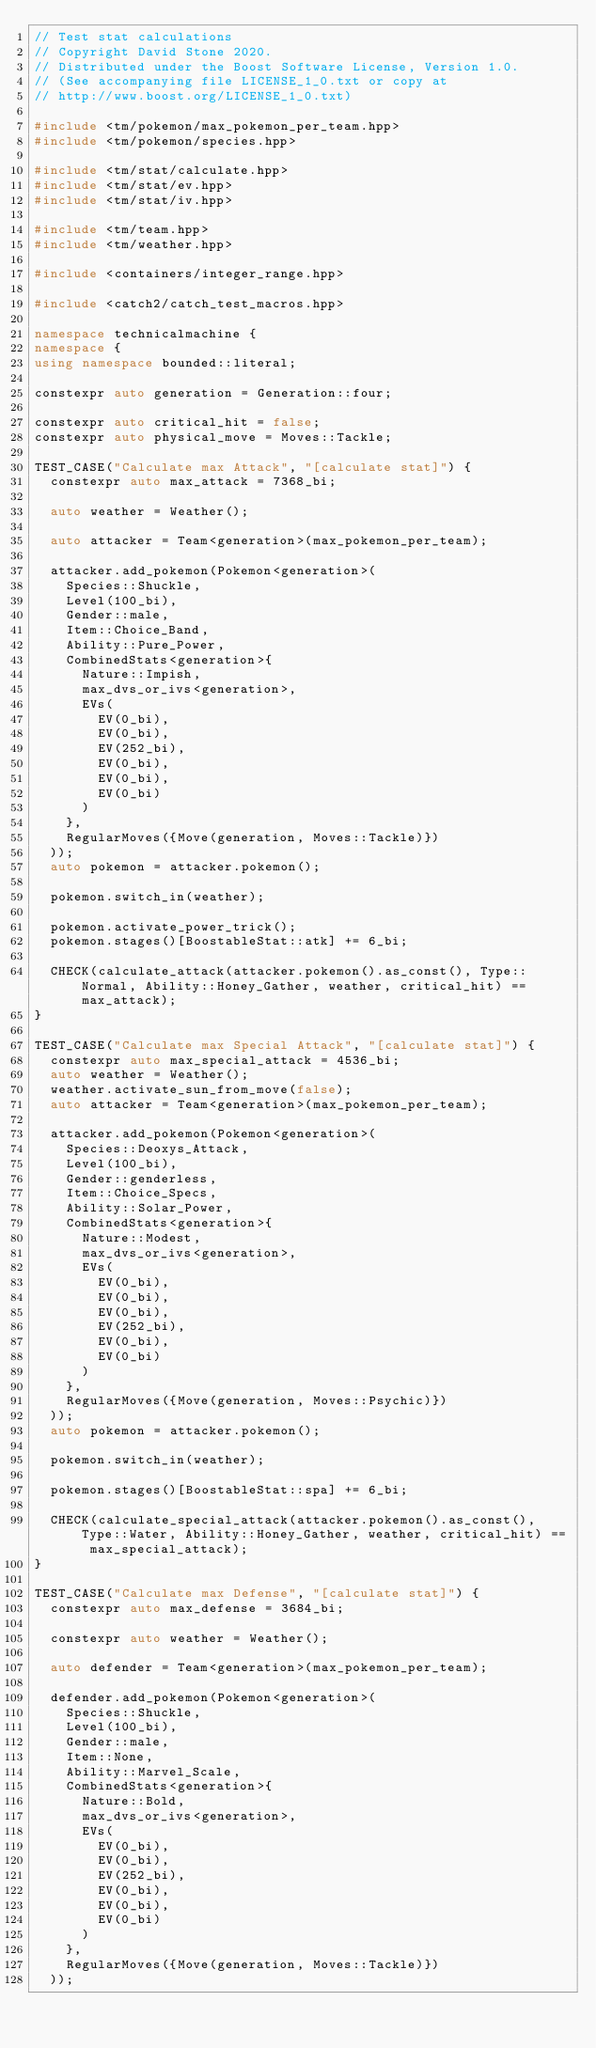<code> <loc_0><loc_0><loc_500><loc_500><_C++_>// Test stat calculations
// Copyright David Stone 2020.
// Distributed under the Boost Software License, Version 1.0.
// (See accompanying file LICENSE_1_0.txt or copy at
// http://www.boost.org/LICENSE_1_0.txt)

#include <tm/pokemon/max_pokemon_per_team.hpp>
#include <tm/pokemon/species.hpp>

#include <tm/stat/calculate.hpp>
#include <tm/stat/ev.hpp>
#include <tm/stat/iv.hpp>

#include <tm/team.hpp>
#include <tm/weather.hpp>

#include <containers/integer_range.hpp>

#include <catch2/catch_test_macros.hpp>

namespace technicalmachine {
namespace {
using namespace bounded::literal;

constexpr auto generation = Generation::four;

constexpr auto critical_hit = false;
constexpr auto physical_move = Moves::Tackle;

TEST_CASE("Calculate max Attack", "[calculate stat]") {
	constexpr auto max_attack = 7368_bi;

	auto weather = Weather();

	auto attacker = Team<generation>(max_pokemon_per_team);

	attacker.add_pokemon(Pokemon<generation>(
		Species::Shuckle,
		Level(100_bi),
		Gender::male,
		Item::Choice_Band,
		Ability::Pure_Power,
		CombinedStats<generation>{
			Nature::Impish,
			max_dvs_or_ivs<generation>,
			EVs(
				EV(0_bi),
				EV(0_bi),
				EV(252_bi),
				EV(0_bi),
				EV(0_bi),
				EV(0_bi)
			)
		},
		RegularMoves({Move(generation, Moves::Tackle)})
	));
	auto pokemon = attacker.pokemon();

	pokemon.switch_in(weather);

	pokemon.activate_power_trick();
	pokemon.stages()[BoostableStat::atk] += 6_bi;

	CHECK(calculate_attack(attacker.pokemon().as_const(), Type::Normal, Ability::Honey_Gather, weather, critical_hit) == max_attack);
}

TEST_CASE("Calculate max Special Attack", "[calculate stat]") {
	constexpr auto max_special_attack = 4536_bi;
	auto weather = Weather();
	weather.activate_sun_from_move(false);
	auto attacker = Team<generation>(max_pokemon_per_team);

	attacker.add_pokemon(Pokemon<generation>(
		Species::Deoxys_Attack,
		Level(100_bi),
		Gender::genderless,
		Item::Choice_Specs,
		Ability::Solar_Power,
		CombinedStats<generation>{
			Nature::Modest,
			max_dvs_or_ivs<generation>,
			EVs(
				EV(0_bi),
				EV(0_bi),
				EV(0_bi),
				EV(252_bi),
				EV(0_bi),
				EV(0_bi)
			)
		},
		RegularMoves({Move(generation, Moves::Psychic)})
	));
	auto pokemon = attacker.pokemon();

	pokemon.switch_in(weather);

	pokemon.stages()[BoostableStat::spa] += 6_bi;

	CHECK(calculate_special_attack(attacker.pokemon().as_const(), Type::Water, Ability::Honey_Gather, weather, critical_hit) == max_special_attack);
}

TEST_CASE("Calculate max Defense", "[calculate stat]") {
	constexpr auto max_defense = 3684_bi;

	constexpr auto weather = Weather();

	auto defender = Team<generation>(max_pokemon_per_team);

	defender.add_pokemon(Pokemon<generation>(
		Species::Shuckle,
		Level(100_bi),
		Gender::male,
		Item::None,
		Ability::Marvel_Scale,
		CombinedStats<generation>{
			Nature::Bold,
			max_dvs_or_ivs<generation>,
			EVs(
				EV(0_bi),
				EV(0_bi),
				EV(252_bi),
				EV(0_bi),
				EV(0_bi),
				EV(0_bi)
			)
		},
		RegularMoves({Move(generation, Moves::Tackle)})
	));</code> 